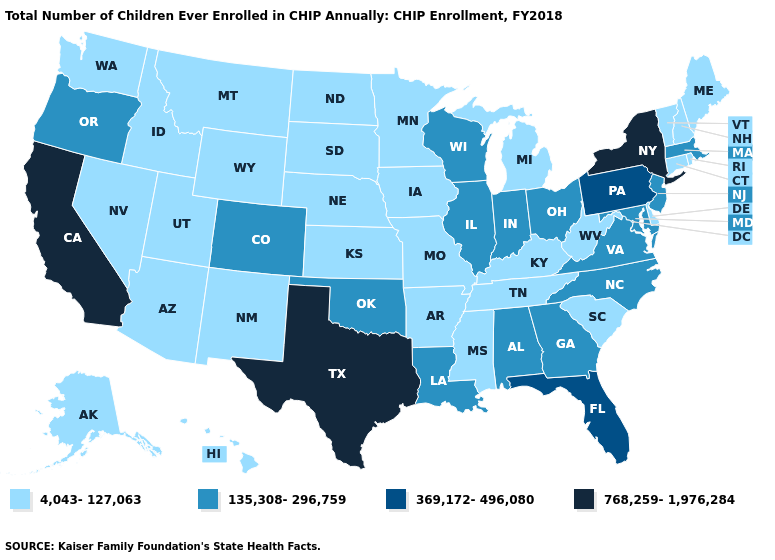What is the highest value in states that border Michigan?
Short answer required. 135,308-296,759. Which states have the lowest value in the USA?
Short answer required. Alaska, Arizona, Arkansas, Connecticut, Delaware, Hawaii, Idaho, Iowa, Kansas, Kentucky, Maine, Michigan, Minnesota, Mississippi, Missouri, Montana, Nebraska, Nevada, New Hampshire, New Mexico, North Dakota, Rhode Island, South Carolina, South Dakota, Tennessee, Utah, Vermont, Washington, West Virginia, Wyoming. Name the states that have a value in the range 135,308-296,759?
Short answer required. Alabama, Colorado, Georgia, Illinois, Indiana, Louisiana, Maryland, Massachusetts, New Jersey, North Carolina, Ohio, Oklahoma, Oregon, Virginia, Wisconsin. Does California have the highest value in the West?
Be succinct. Yes. What is the highest value in the USA?
Give a very brief answer. 768,259-1,976,284. What is the value of New Jersey?
Write a very short answer. 135,308-296,759. Does Wisconsin have the lowest value in the MidWest?
Be succinct. No. Which states have the lowest value in the MidWest?
Short answer required. Iowa, Kansas, Michigan, Minnesota, Missouri, Nebraska, North Dakota, South Dakota. Which states have the lowest value in the West?
Write a very short answer. Alaska, Arizona, Hawaii, Idaho, Montana, Nevada, New Mexico, Utah, Washington, Wyoming. What is the value of North Carolina?
Answer briefly. 135,308-296,759. What is the value of Massachusetts?
Answer briefly. 135,308-296,759. What is the value of Arkansas?
Concise answer only. 4,043-127,063. Name the states that have a value in the range 768,259-1,976,284?
Write a very short answer. California, New York, Texas. What is the value of Nebraska?
Concise answer only. 4,043-127,063. Does Indiana have a lower value than Arkansas?
Short answer required. No. 